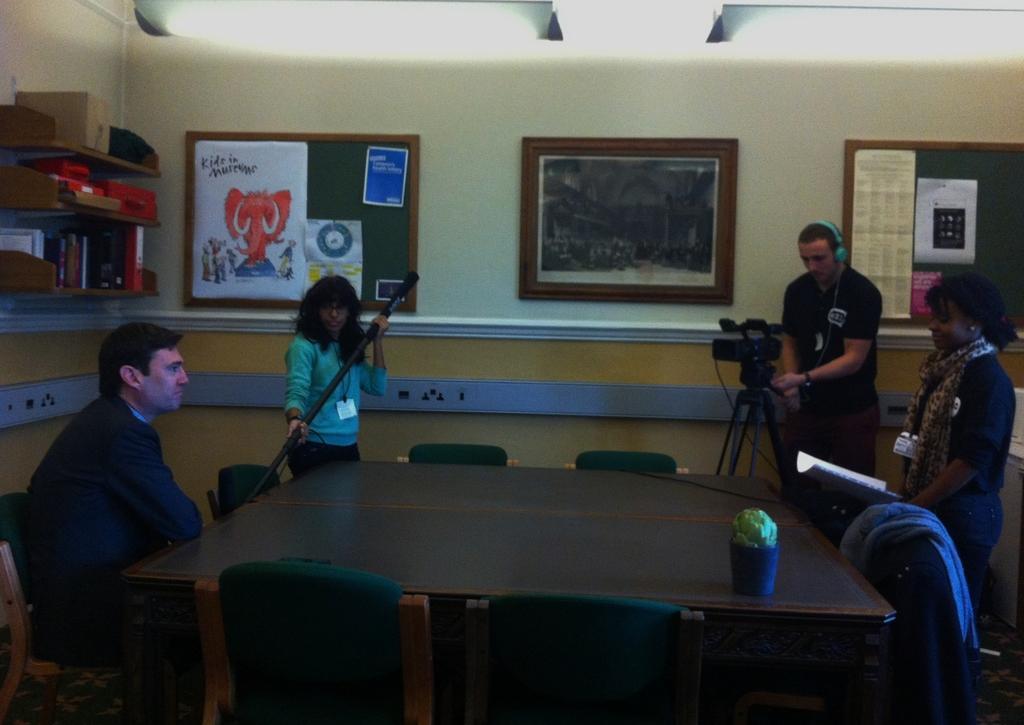Can you describe this image briefly? In this picture there is a man who is sitting at the left side of the image and there are some people those who are taking the video from the right side of the image and there is a table in between the chairs at the center of the image there are boards at center of the image. 